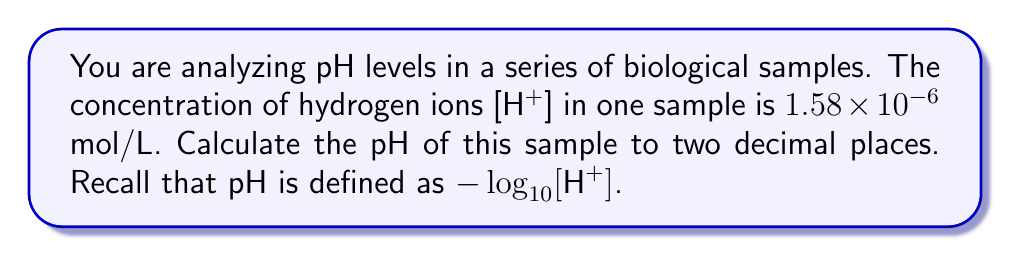Show me your answer to this math problem. Let's approach this step-by-step:

1) The formula for pH is:
   $$ pH = -\log_{10}[H^+] $$

2) We're given that $[H^+] = 1.58 \times 10^{-6}$ mol/L

3) Let's substitute this into our equation:
   $$ pH = -\log_{10}(1.58 \times 10^{-6}) $$

4) We can split this logarithm using the product rule of logarithms:
   $$ pH = -(\log_{10}(1.58) + \log_{10}(10^{-6})) $$

5) Simplify the second term:
   $$ pH = -(\log_{10}(1.58) + (-6)) $$

6) Using a calculator or logarithm table for $\log_{10}(1.58)$:
   $$ pH = -(0.19866 + (-6)) $$

7) Simplify inside the parentheses:
   $$ pH = -(0.19866 - 6) = -(-5.80134) $$

8) Therefore:
   $$ pH = 5.80134 $$

9) Rounding to two decimal places:
   $$ pH = 5.80 $$
Answer: 5.80 